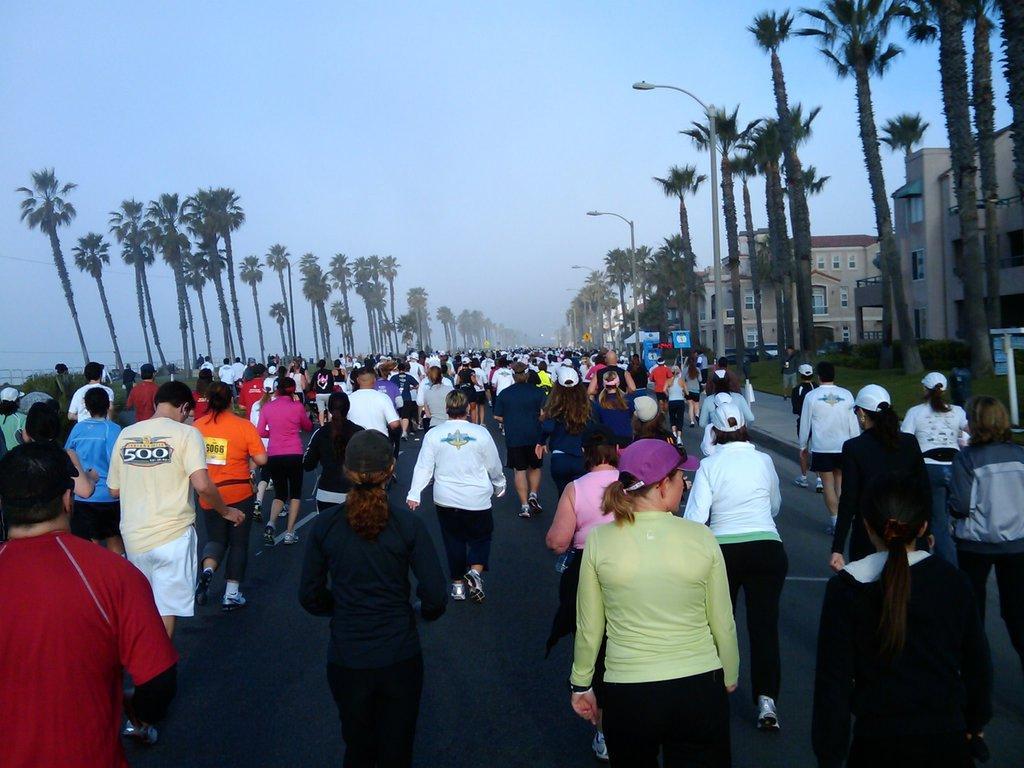Please provide a concise description of this image. people walking on the road as we can see in the middle of this image. There are some trees in the background, and there are some buildings on the right side of this image, and there is a sky at the top of this image. 